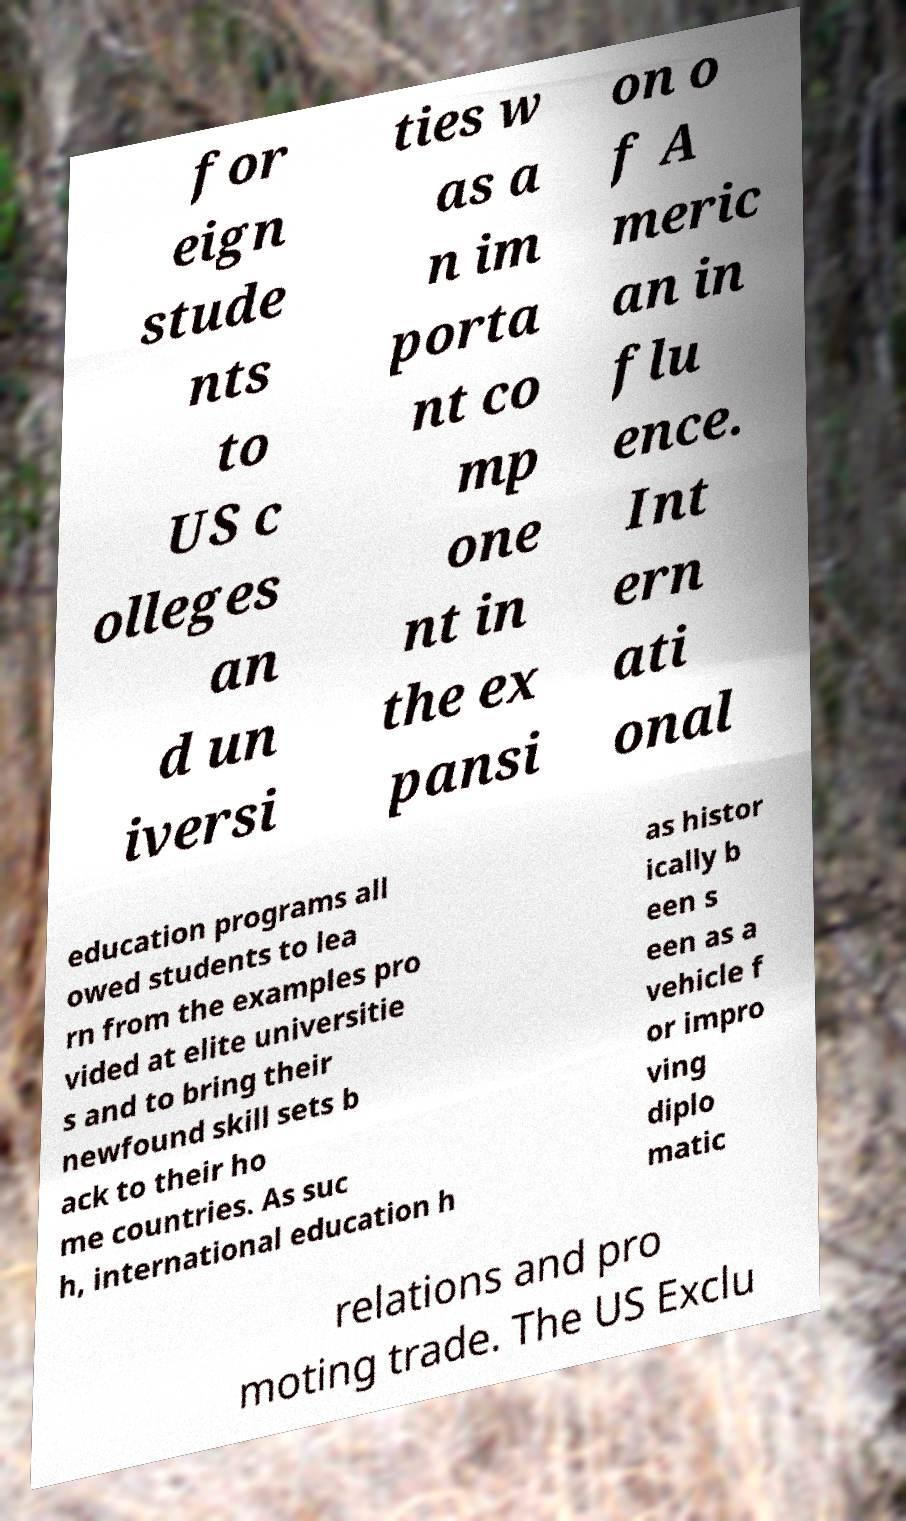For documentation purposes, I need the text within this image transcribed. Could you provide that? for eign stude nts to US c olleges an d un iversi ties w as a n im porta nt co mp one nt in the ex pansi on o f A meric an in flu ence. Int ern ati onal education programs all owed students to lea rn from the examples pro vided at elite universitie s and to bring their newfound skill sets b ack to their ho me countries. As suc h, international education h as histor ically b een s een as a vehicle f or impro ving diplo matic relations and pro moting trade. The US Exclu 